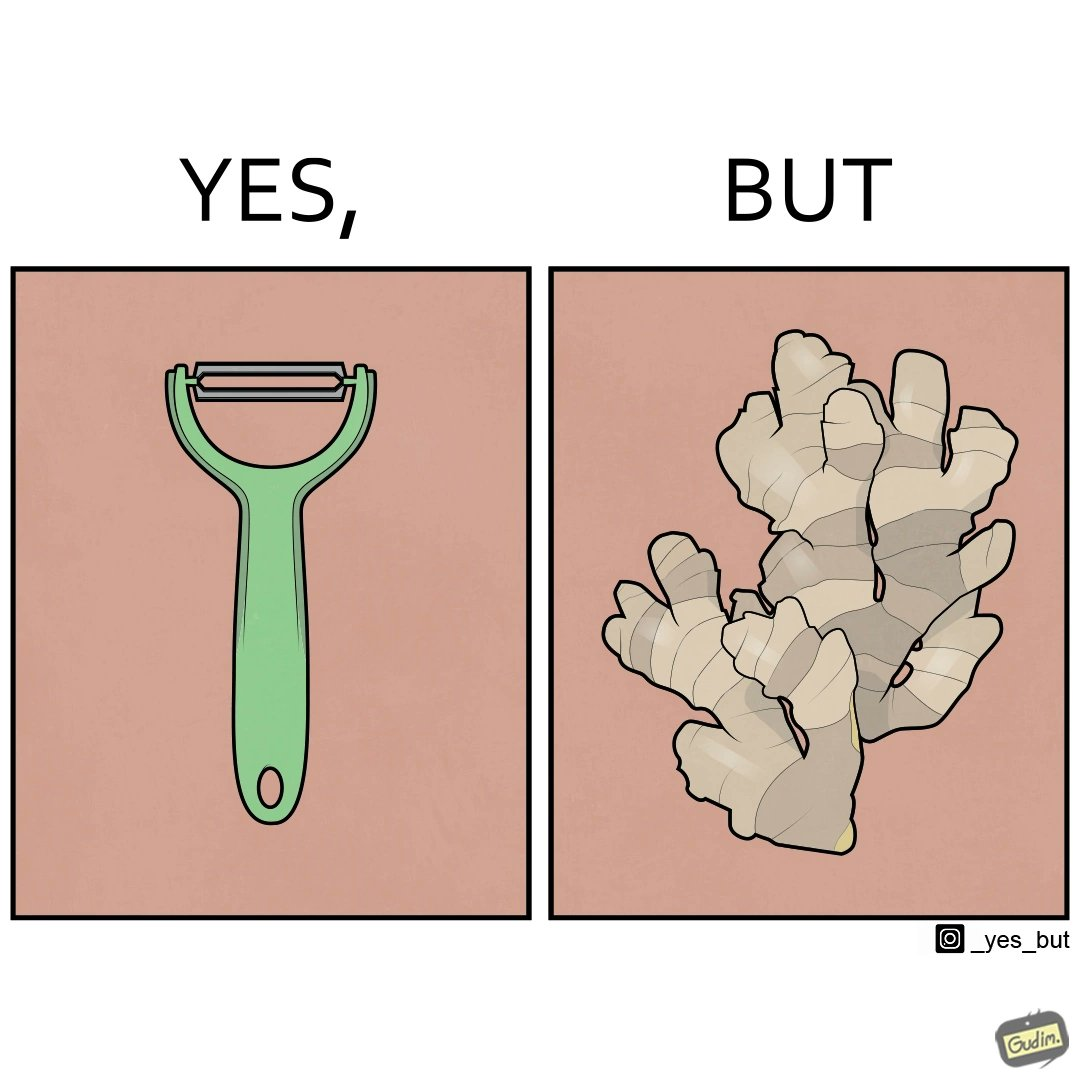Would you classify this image as satirical? Yes, this image is satirical. 